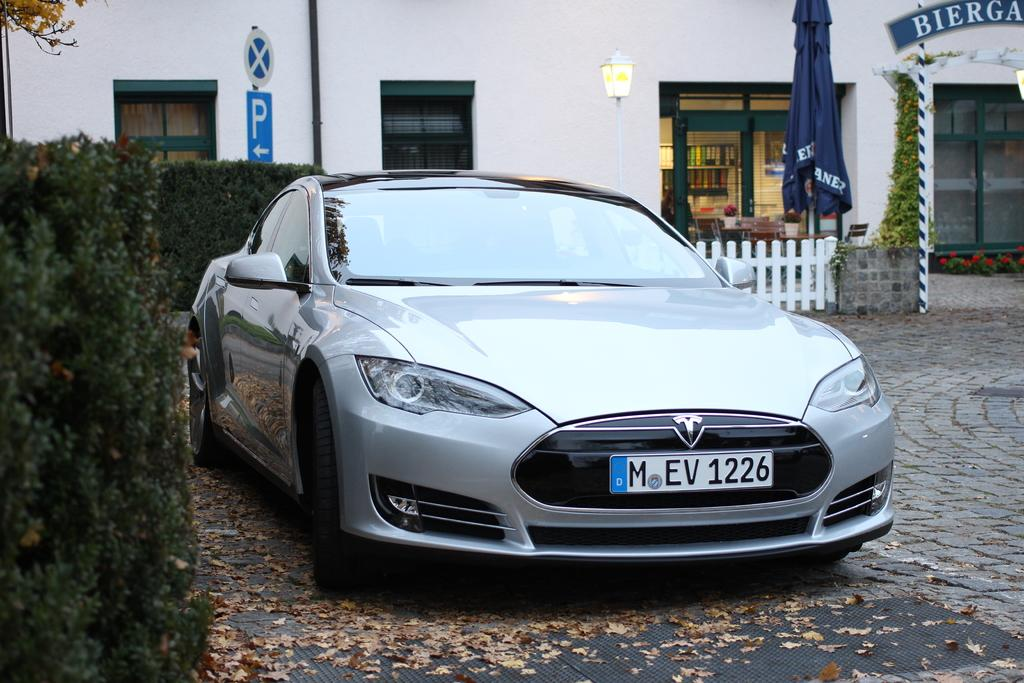What color is the car in the image? The car in the image is silver-colored. What type of vegetation can be seen in the image? There are green-colored plants in the image. What can be seen in the background of the image? In the background of the image, there is a blue-colored flag, a white-colored building, windows, and a stall. How does the woman adjust the basket in the image? There is no woman or basket present in the image. 